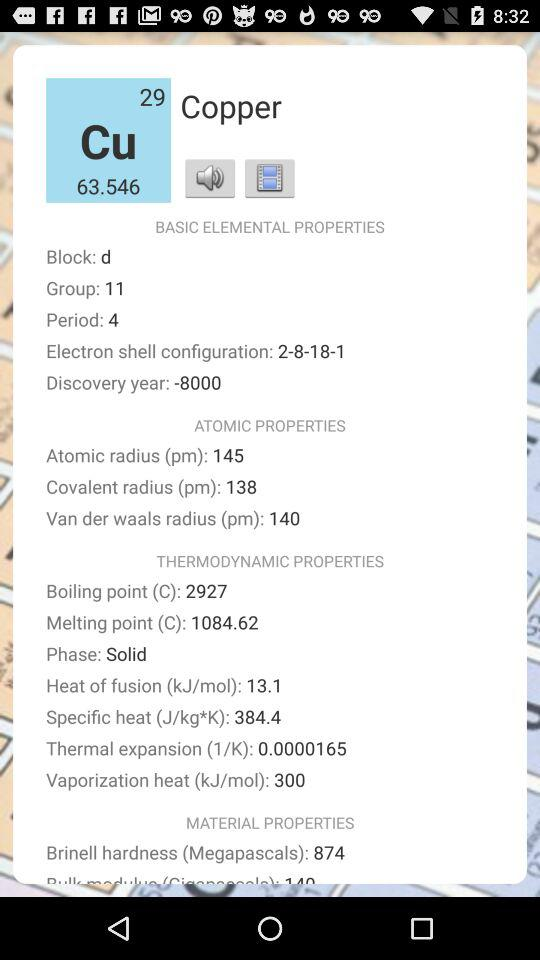What is the year of discovery? The year of discovery is -8000. 